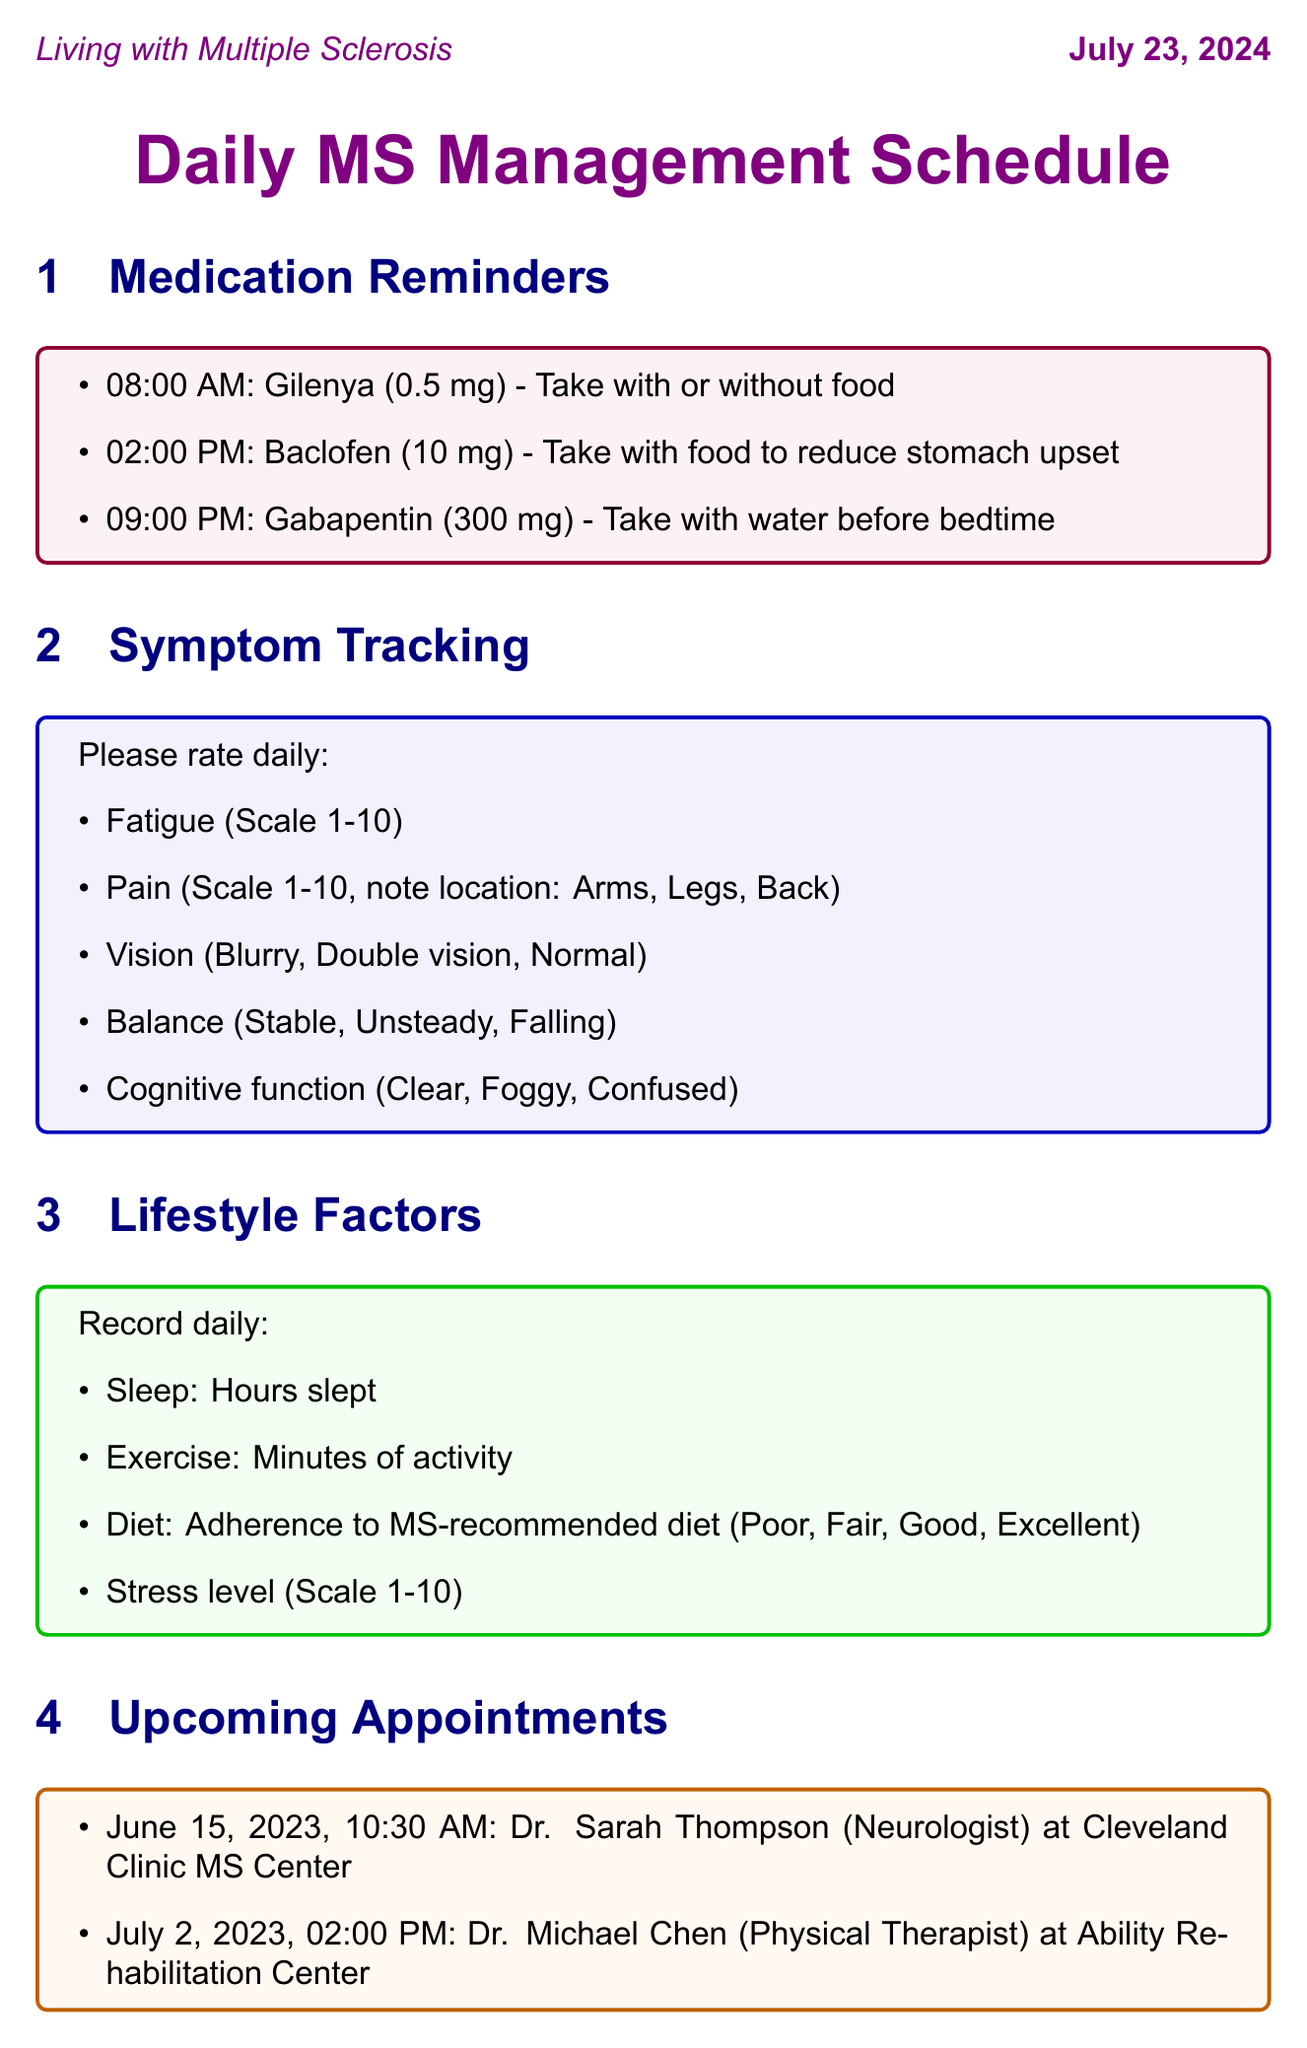What medication is taken at 08:00 AM? The medication listed for that time is Gilenya.
Answer: Gilenya How often should fatigue be tracked? The document states that fatigue should be rated daily.
Answer: Daily What is the dosage of Baclofen? The dosage of Baclofen mentioned in the medication reminders is 10 mg.
Answer: 10 mg What are the two components of the lifestyle factors tracked? The lifestyle factors include sleep and exercise tracking.
Answer: Sleep, exercise On what date is the appointment with Dr. Sarah Thompson scheduled? According to the document, the appointment is on June 15, 2023.
Answer: June 15, 2023 How many journal prompts are provided? There are five journal prompts listed in the schedule.
Answer: Five What scale is used to rate stress level? The stress level is rated on a scale of 1 to 10.
Answer: 1-10 Which resource provides information on support groups? The resource that offers information on support groups is the National Multiple Sclerosis Society.
Answer: National Multiple Sclerosis Society 